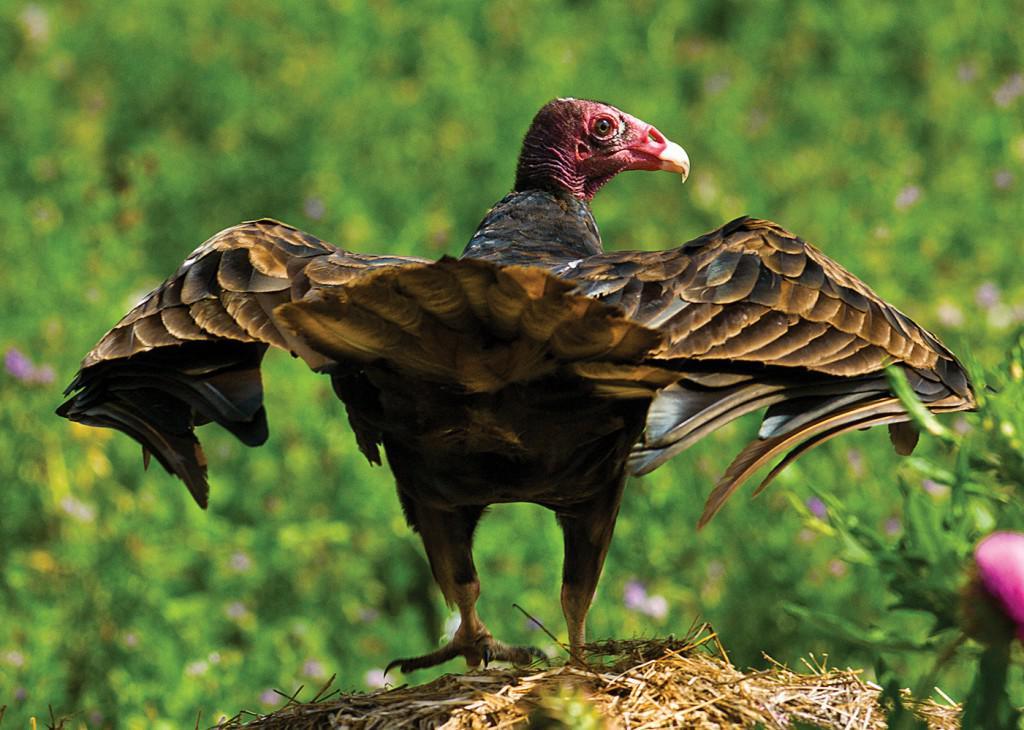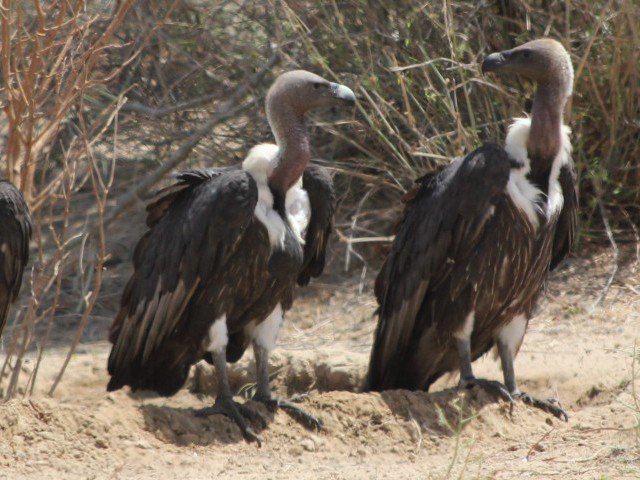The first image is the image on the left, the second image is the image on the right. Evaluate the accuracy of this statement regarding the images: "In the image to the right, two vultures rest, wings closed.". Is it true? Answer yes or no. Yes. The first image is the image on the left, the second image is the image on the right. For the images shown, is this caption "The right image includes two vultures standing face-to-face." true? Answer yes or no. Yes. 